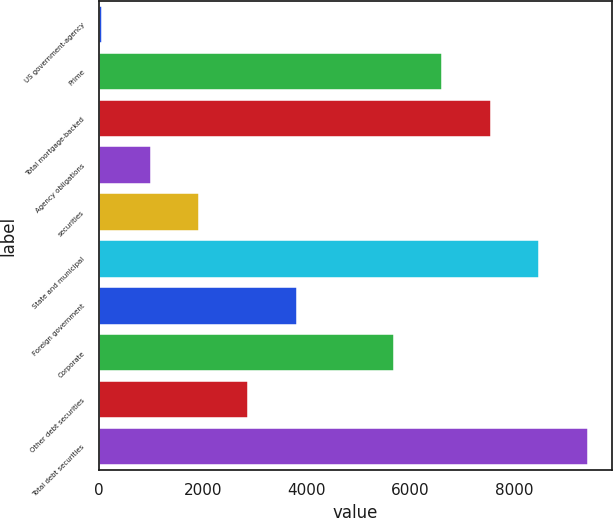Convert chart to OTSL. <chart><loc_0><loc_0><loc_500><loc_500><bar_chart><fcel>US government-agency<fcel>Prime<fcel>Total mortgage-backed<fcel>Agency obligations<fcel>securities<fcel>State and municipal<fcel>Foreign government<fcel>Corporate<fcel>Other debt securities<fcel>Total debt securities<nl><fcel>67<fcel>6609.9<fcel>7544.6<fcel>1001.7<fcel>1936.4<fcel>8479.3<fcel>3805.8<fcel>5675.2<fcel>2871.1<fcel>9414<nl></chart> 